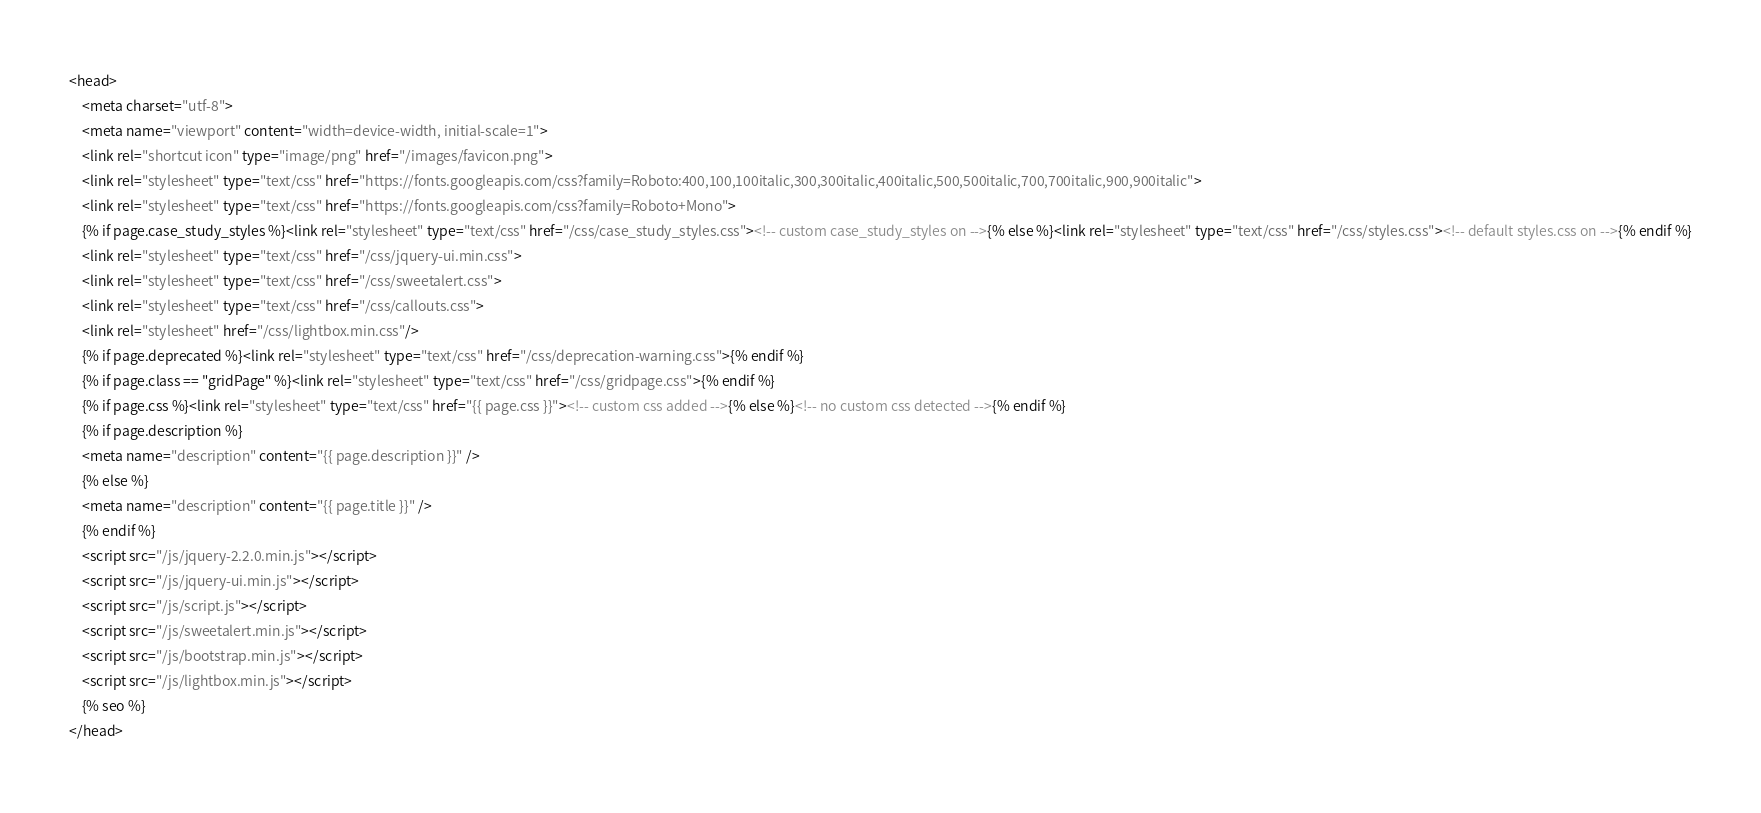Convert code to text. <code><loc_0><loc_0><loc_500><loc_500><_HTML_><head>
    <meta charset="utf-8">
    <meta name="viewport" content="width=device-width, initial-scale=1">
    <link rel="shortcut icon" type="image/png" href="/images/favicon.png">
    <link rel="stylesheet" type="text/css" href="https://fonts.googleapis.com/css?family=Roboto:400,100,100italic,300,300italic,400italic,500,500italic,700,700italic,900,900italic">
    <link rel="stylesheet" type="text/css" href="https://fonts.googleapis.com/css?family=Roboto+Mono">
    {% if page.case_study_styles %}<link rel="stylesheet" type="text/css" href="/css/case_study_styles.css"><!-- custom case_study_styles on -->{% else %}<link rel="stylesheet" type="text/css" href="/css/styles.css"><!-- default styles.css on -->{% endif %}
    <link rel="stylesheet" type="text/css" href="/css/jquery-ui.min.css">
    <link rel="stylesheet" type="text/css" href="/css/sweetalert.css">
    <link rel="stylesheet" type="text/css" href="/css/callouts.css">
    <link rel="stylesheet" href="/css/lightbox.min.css"/>
    {% if page.deprecated %}<link rel="stylesheet" type="text/css" href="/css/deprecation-warning.css">{% endif %}
    {% if page.class == "gridPage" %}<link rel="stylesheet" type="text/css" href="/css/gridpage.css">{% endif %}
    {% if page.css %}<link rel="stylesheet" type="text/css" href="{{ page.css }}"><!-- custom css added -->{% else %}<!-- no custom css detected -->{% endif %}
    {% if page.description %}
    <meta name="description" content="{{ page.description }}" />
    {% else %}
    <meta name="description" content="{{ page.title }}" />
    {% endif %}
    <script src="/js/jquery-2.2.0.min.js"></script>
    <script src="/js/jquery-ui.min.js"></script>
    <script src="/js/script.js"></script>
    <script src="/js/sweetalert.min.js"></script>
    <script src="/js/bootstrap.min.js"></script>
    <script src="/js/lightbox.min.js"></script>
    {% seo %}
</head>
</code> 